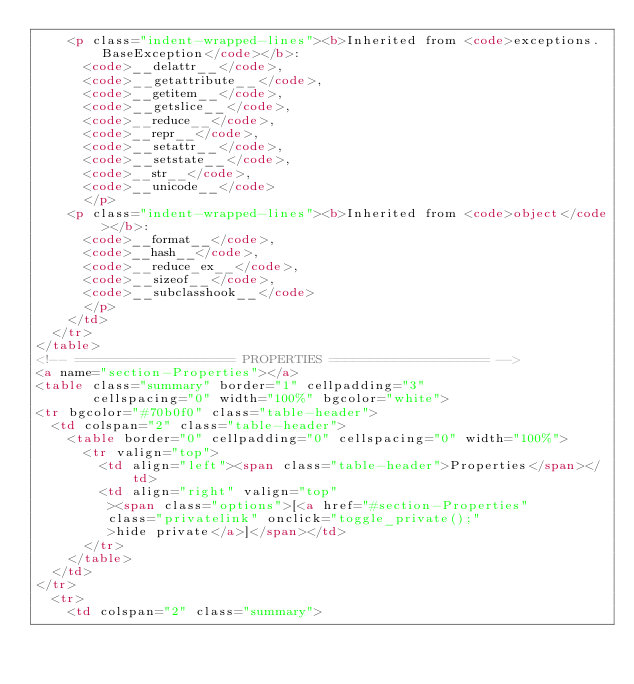Convert code to text. <code><loc_0><loc_0><loc_500><loc_500><_HTML_>    <p class="indent-wrapped-lines"><b>Inherited from <code>exceptions.BaseException</code></b>:
      <code>__delattr__</code>,
      <code>__getattribute__</code>,
      <code>__getitem__</code>,
      <code>__getslice__</code>,
      <code>__reduce__</code>,
      <code>__repr__</code>,
      <code>__setattr__</code>,
      <code>__setstate__</code>,
      <code>__str__</code>,
      <code>__unicode__</code>
      </p>
    <p class="indent-wrapped-lines"><b>Inherited from <code>object</code></b>:
      <code>__format__</code>,
      <code>__hash__</code>,
      <code>__reduce_ex__</code>,
      <code>__sizeof__</code>,
      <code>__subclasshook__</code>
      </p>
    </td>
  </tr>
</table>
<!-- ==================== PROPERTIES ==================== -->
<a name="section-Properties"></a>
<table class="summary" border="1" cellpadding="3"
       cellspacing="0" width="100%" bgcolor="white">
<tr bgcolor="#70b0f0" class="table-header">
  <td colspan="2" class="table-header">
    <table border="0" cellpadding="0" cellspacing="0" width="100%">
      <tr valign="top">
        <td align="left"><span class="table-header">Properties</span></td>
        <td align="right" valign="top"
         ><span class="options">[<a href="#section-Properties"
         class="privatelink" onclick="toggle_private();"
         >hide private</a>]</span></td>
      </tr>
    </table>
  </td>
</tr>
  <tr>
    <td colspan="2" class="summary"></code> 